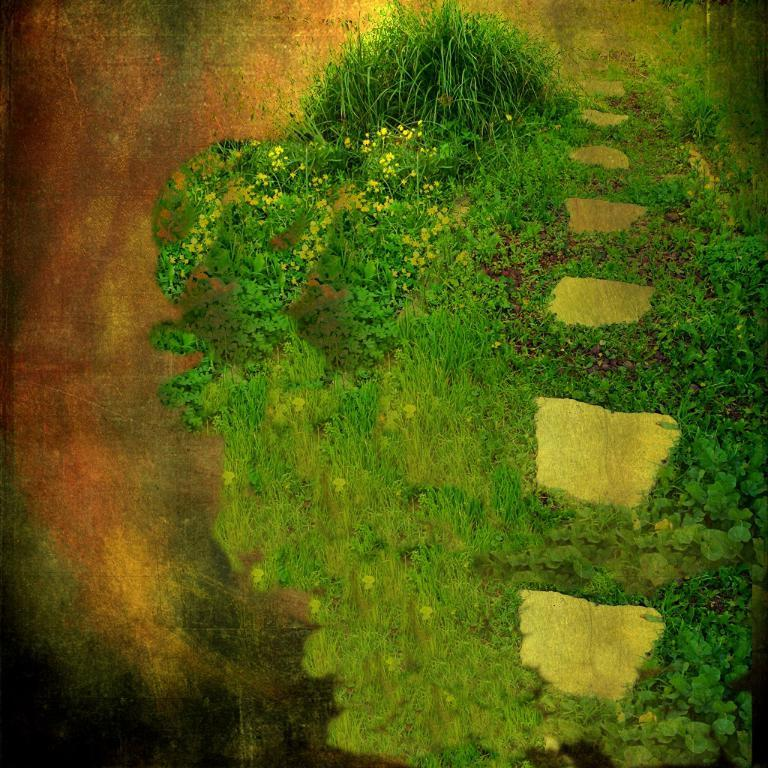What type of image is being described? The image is an edited picture. What type of natural environment is depicted in the image? There is grass and plants in the image. Can you see a hose watering the plants in the image? There is no hose visible in the image. Is there a donkey grazing on the grass in the image? There is no donkey present in the image. 